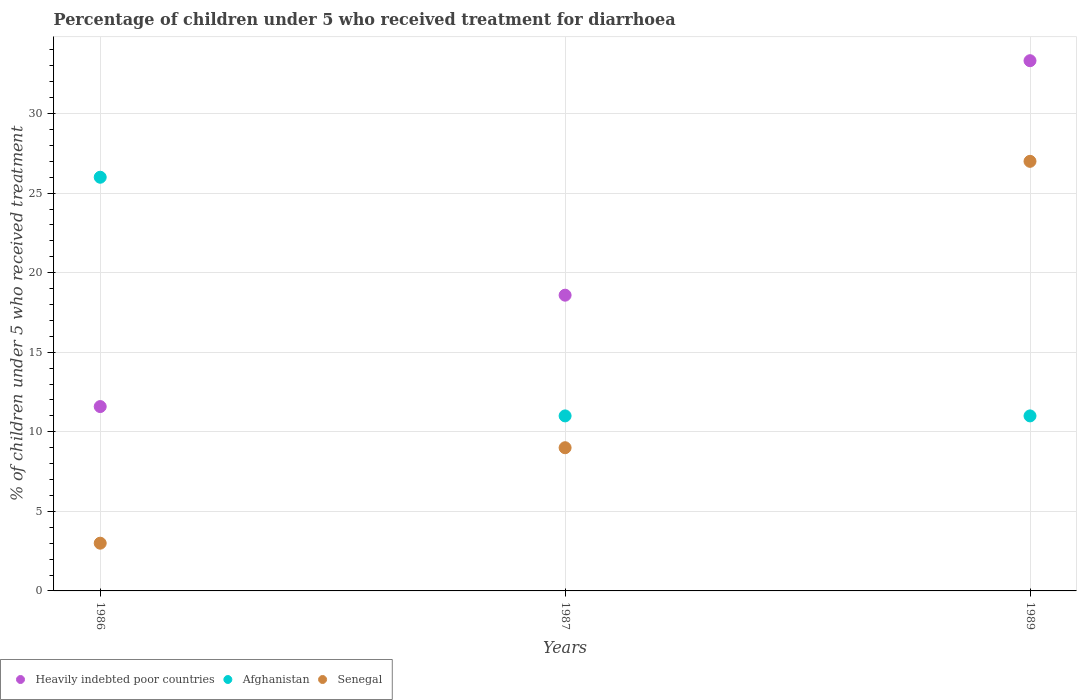What is the percentage of children who received treatment for diarrhoea  in Heavily indebted poor countries in 1989?
Offer a very short reply. 33.33. Across all years, what is the maximum percentage of children who received treatment for diarrhoea  in Heavily indebted poor countries?
Your response must be concise. 33.33. Across all years, what is the minimum percentage of children who received treatment for diarrhoea  in Heavily indebted poor countries?
Provide a succinct answer. 11.59. What is the total percentage of children who received treatment for diarrhoea  in Heavily indebted poor countries in the graph?
Provide a short and direct response. 63.5. What is the difference between the percentage of children who received treatment for diarrhoea  in Heavily indebted poor countries in 1987 and that in 1989?
Ensure brevity in your answer.  -14.74. What is the difference between the percentage of children who received treatment for diarrhoea  in Senegal in 1989 and the percentage of children who received treatment for diarrhoea  in Afghanistan in 1987?
Offer a terse response. 16. What is the average percentage of children who received treatment for diarrhoea  in Afghanistan per year?
Give a very brief answer. 16. In the year 1986, what is the difference between the percentage of children who received treatment for diarrhoea  in Heavily indebted poor countries and percentage of children who received treatment for diarrhoea  in Afghanistan?
Make the answer very short. -14.41. What is the ratio of the percentage of children who received treatment for diarrhoea  in Senegal in 1986 to that in 1989?
Make the answer very short. 0.11. Is the percentage of children who received treatment for diarrhoea  in Afghanistan in 1986 less than that in 1989?
Make the answer very short. No. What is the difference between the highest and the second highest percentage of children who received treatment for diarrhoea  in Senegal?
Your answer should be compact. 18. What is the difference between the highest and the lowest percentage of children who received treatment for diarrhoea  in Afghanistan?
Provide a succinct answer. 15. In how many years, is the percentage of children who received treatment for diarrhoea  in Senegal greater than the average percentage of children who received treatment for diarrhoea  in Senegal taken over all years?
Keep it short and to the point. 1. Is the sum of the percentage of children who received treatment for diarrhoea  in Heavily indebted poor countries in 1986 and 1989 greater than the maximum percentage of children who received treatment for diarrhoea  in Senegal across all years?
Your answer should be very brief. Yes. Is it the case that in every year, the sum of the percentage of children who received treatment for diarrhoea  in Afghanistan and percentage of children who received treatment for diarrhoea  in Heavily indebted poor countries  is greater than the percentage of children who received treatment for diarrhoea  in Senegal?
Give a very brief answer. Yes. Does the percentage of children who received treatment for diarrhoea  in Afghanistan monotonically increase over the years?
Give a very brief answer. No. Is the percentage of children who received treatment for diarrhoea  in Heavily indebted poor countries strictly less than the percentage of children who received treatment for diarrhoea  in Afghanistan over the years?
Your response must be concise. No. How many years are there in the graph?
Give a very brief answer. 3. Does the graph contain grids?
Offer a terse response. Yes. How many legend labels are there?
Ensure brevity in your answer.  3. What is the title of the graph?
Offer a very short reply. Percentage of children under 5 who received treatment for diarrhoea. What is the label or title of the Y-axis?
Provide a succinct answer. % of children under 5 who received treatment. What is the % of children under 5 who received treatment in Heavily indebted poor countries in 1986?
Your answer should be very brief. 11.59. What is the % of children under 5 who received treatment in Afghanistan in 1986?
Your answer should be compact. 26. What is the % of children under 5 who received treatment in Heavily indebted poor countries in 1987?
Give a very brief answer. 18.59. What is the % of children under 5 who received treatment in Afghanistan in 1987?
Make the answer very short. 11. What is the % of children under 5 who received treatment in Heavily indebted poor countries in 1989?
Provide a short and direct response. 33.33. Across all years, what is the maximum % of children under 5 who received treatment in Heavily indebted poor countries?
Give a very brief answer. 33.33. Across all years, what is the maximum % of children under 5 who received treatment in Afghanistan?
Provide a short and direct response. 26. Across all years, what is the maximum % of children under 5 who received treatment in Senegal?
Your answer should be very brief. 27. Across all years, what is the minimum % of children under 5 who received treatment in Heavily indebted poor countries?
Your answer should be very brief. 11.59. Across all years, what is the minimum % of children under 5 who received treatment of Afghanistan?
Keep it short and to the point. 11. What is the total % of children under 5 who received treatment of Heavily indebted poor countries in the graph?
Your answer should be compact. 63.5. What is the difference between the % of children under 5 who received treatment of Heavily indebted poor countries in 1986 and that in 1987?
Keep it short and to the point. -7. What is the difference between the % of children under 5 who received treatment in Heavily indebted poor countries in 1986 and that in 1989?
Keep it short and to the point. -21.74. What is the difference between the % of children under 5 who received treatment of Heavily indebted poor countries in 1987 and that in 1989?
Your answer should be very brief. -14.74. What is the difference between the % of children under 5 who received treatment in Senegal in 1987 and that in 1989?
Give a very brief answer. -18. What is the difference between the % of children under 5 who received treatment in Heavily indebted poor countries in 1986 and the % of children under 5 who received treatment in Afghanistan in 1987?
Give a very brief answer. 0.59. What is the difference between the % of children under 5 who received treatment of Heavily indebted poor countries in 1986 and the % of children under 5 who received treatment of Senegal in 1987?
Keep it short and to the point. 2.59. What is the difference between the % of children under 5 who received treatment of Heavily indebted poor countries in 1986 and the % of children under 5 who received treatment of Afghanistan in 1989?
Give a very brief answer. 0.59. What is the difference between the % of children under 5 who received treatment of Heavily indebted poor countries in 1986 and the % of children under 5 who received treatment of Senegal in 1989?
Ensure brevity in your answer.  -15.41. What is the difference between the % of children under 5 who received treatment of Heavily indebted poor countries in 1987 and the % of children under 5 who received treatment of Afghanistan in 1989?
Provide a short and direct response. 7.59. What is the difference between the % of children under 5 who received treatment in Heavily indebted poor countries in 1987 and the % of children under 5 who received treatment in Senegal in 1989?
Keep it short and to the point. -8.41. What is the difference between the % of children under 5 who received treatment of Afghanistan in 1987 and the % of children under 5 who received treatment of Senegal in 1989?
Make the answer very short. -16. What is the average % of children under 5 who received treatment of Heavily indebted poor countries per year?
Ensure brevity in your answer.  21.17. What is the average % of children under 5 who received treatment of Afghanistan per year?
Provide a short and direct response. 16. In the year 1986, what is the difference between the % of children under 5 who received treatment of Heavily indebted poor countries and % of children under 5 who received treatment of Afghanistan?
Your answer should be very brief. -14.41. In the year 1986, what is the difference between the % of children under 5 who received treatment in Heavily indebted poor countries and % of children under 5 who received treatment in Senegal?
Provide a succinct answer. 8.59. In the year 1986, what is the difference between the % of children under 5 who received treatment of Afghanistan and % of children under 5 who received treatment of Senegal?
Your answer should be very brief. 23. In the year 1987, what is the difference between the % of children under 5 who received treatment of Heavily indebted poor countries and % of children under 5 who received treatment of Afghanistan?
Your answer should be very brief. 7.59. In the year 1987, what is the difference between the % of children under 5 who received treatment of Heavily indebted poor countries and % of children under 5 who received treatment of Senegal?
Your answer should be very brief. 9.59. In the year 1987, what is the difference between the % of children under 5 who received treatment in Afghanistan and % of children under 5 who received treatment in Senegal?
Offer a very short reply. 2. In the year 1989, what is the difference between the % of children under 5 who received treatment in Heavily indebted poor countries and % of children under 5 who received treatment in Afghanistan?
Your answer should be compact. 22.32. In the year 1989, what is the difference between the % of children under 5 who received treatment of Heavily indebted poor countries and % of children under 5 who received treatment of Senegal?
Give a very brief answer. 6.33. In the year 1989, what is the difference between the % of children under 5 who received treatment in Afghanistan and % of children under 5 who received treatment in Senegal?
Your answer should be very brief. -16. What is the ratio of the % of children under 5 who received treatment in Heavily indebted poor countries in 1986 to that in 1987?
Give a very brief answer. 0.62. What is the ratio of the % of children under 5 who received treatment of Afghanistan in 1986 to that in 1987?
Give a very brief answer. 2.36. What is the ratio of the % of children under 5 who received treatment in Heavily indebted poor countries in 1986 to that in 1989?
Your answer should be very brief. 0.35. What is the ratio of the % of children under 5 who received treatment in Afghanistan in 1986 to that in 1989?
Offer a very short reply. 2.36. What is the ratio of the % of children under 5 who received treatment of Heavily indebted poor countries in 1987 to that in 1989?
Keep it short and to the point. 0.56. What is the difference between the highest and the second highest % of children under 5 who received treatment of Heavily indebted poor countries?
Ensure brevity in your answer.  14.74. What is the difference between the highest and the lowest % of children under 5 who received treatment of Heavily indebted poor countries?
Your answer should be compact. 21.74. 